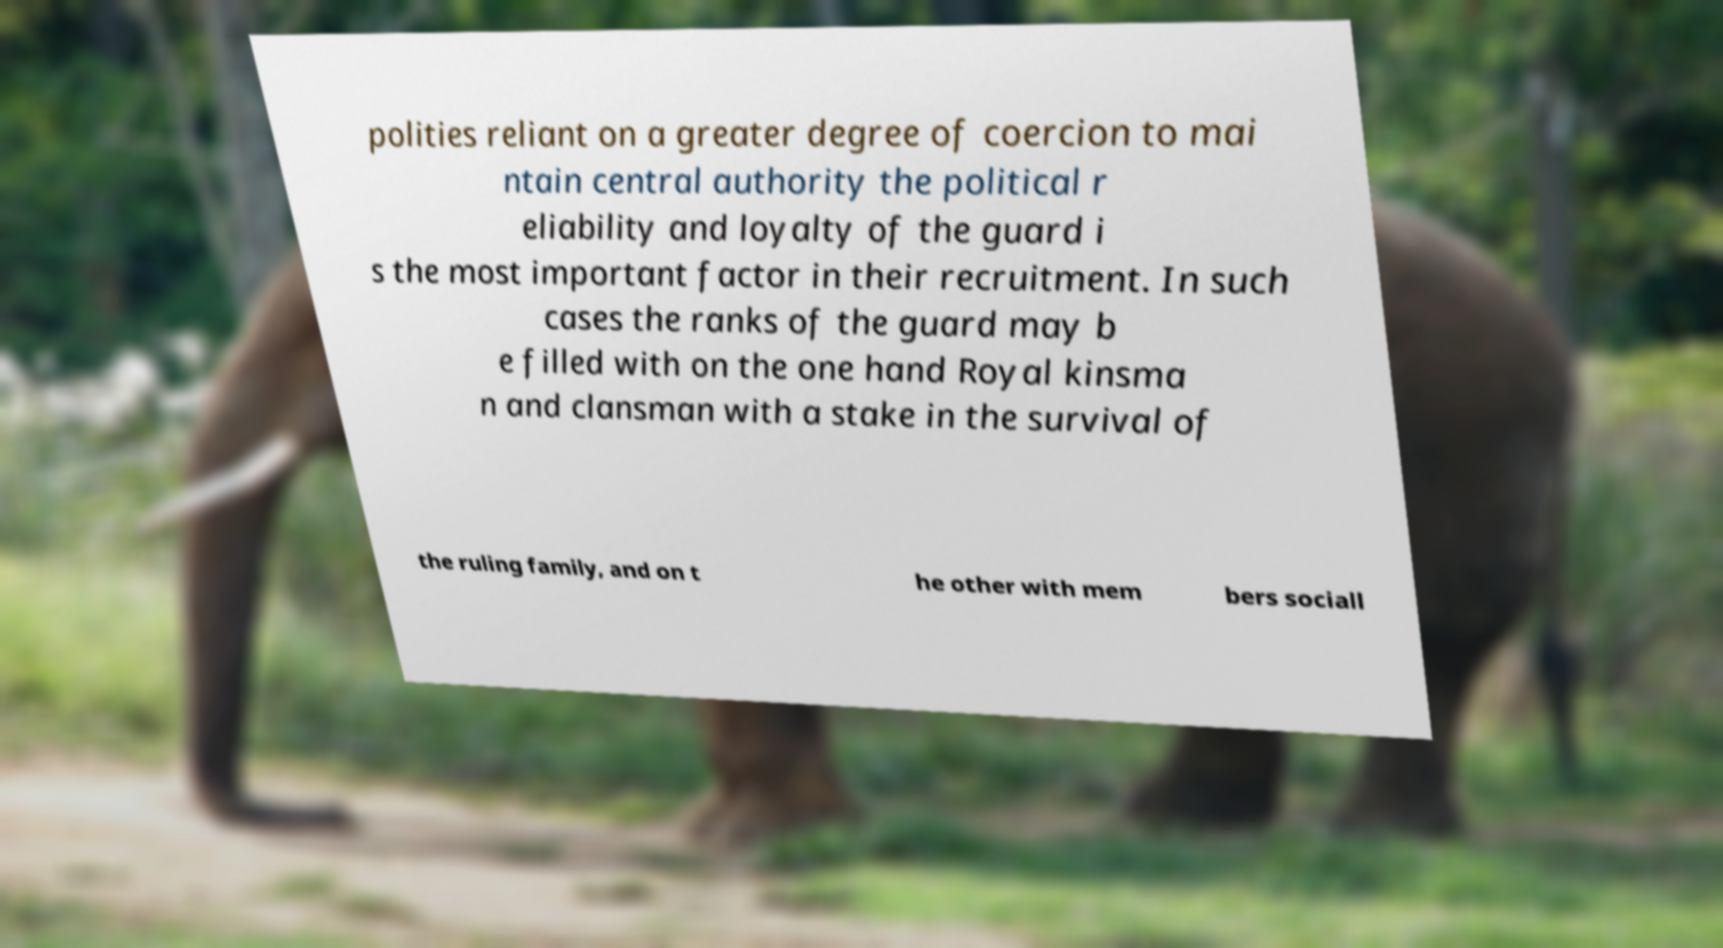Could you assist in decoding the text presented in this image and type it out clearly? polities reliant on a greater degree of coercion to mai ntain central authority the political r eliability and loyalty of the guard i s the most important factor in their recruitment. In such cases the ranks of the guard may b e filled with on the one hand Royal kinsma n and clansman with a stake in the survival of the ruling family, and on t he other with mem bers sociall 